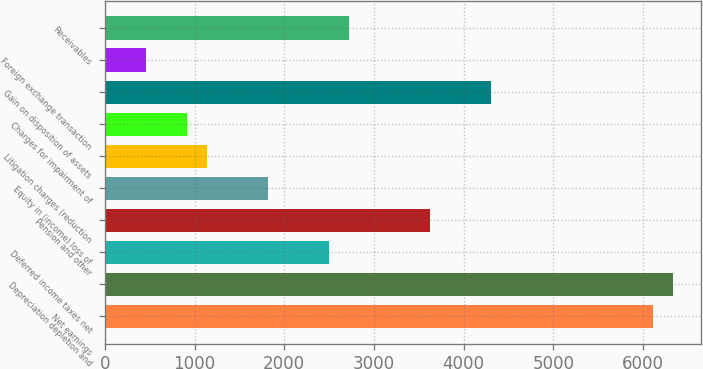<chart> <loc_0><loc_0><loc_500><loc_500><bar_chart><fcel>Net earnings<fcel>Depreciation depletion and<fcel>Deferred income taxes net<fcel>Pension and other<fcel>Equity in (income) loss of<fcel>Litigation charges (reduction<fcel>Charges for impairment of<fcel>Gain on disposition of assets<fcel>Foreign exchange transaction<fcel>Receivables<nl><fcel>6108.3<fcel>6334.2<fcel>2493.9<fcel>3623.4<fcel>1816.2<fcel>1138.5<fcel>912.6<fcel>4301.1<fcel>460.8<fcel>2719.8<nl></chart> 